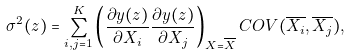<formula> <loc_0><loc_0><loc_500><loc_500>\sigma ^ { 2 } ( z ) = \sum ^ { K } _ { i , j = 1 } \left ( \frac { \partial y ( z ) } { \partial X _ { i } } \frac { \partial y ( z ) } { \partial X _ { j } } \right ) _ { X = \overline { X } } C O V ( \overline { X _ { i } } , \overline { X _ { j } } ) ,</formula> 